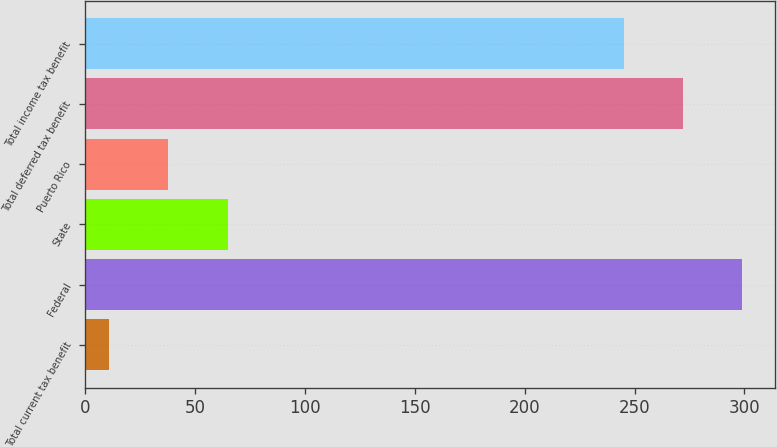Convert chart to OTSL. <chart><loc_0><loc_0><loc_500><loc_500><bar_chart><fcel>Total current tax benefit<fcel>Federal<fcel>State<fcel>Puerto Rico<fcel>Total deferred tax benefit<fcel>Total income tax benefit<nl><fcel>11<fcel>299<fcel>65<fcel>38<fcel>272<fcel>245<nl></chart> 